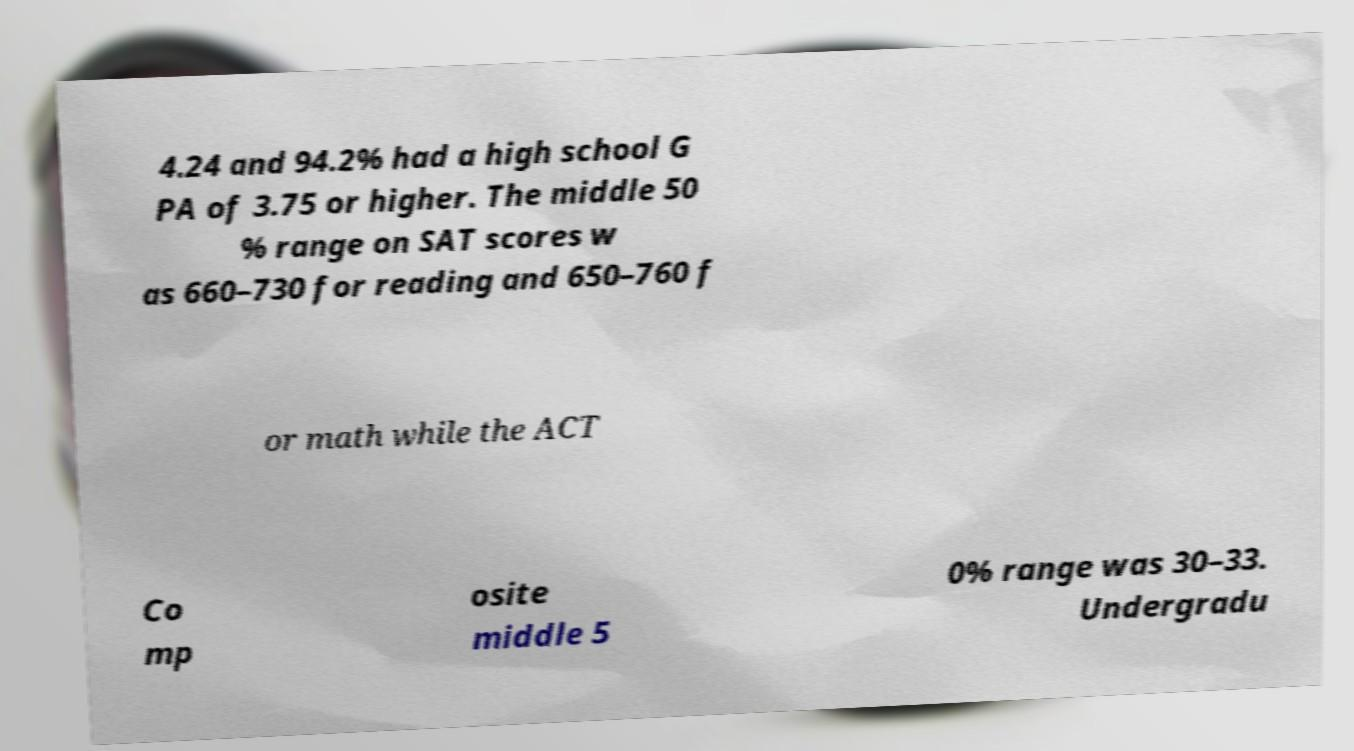Could you assist in decoding the text presented in this image and type it out clearly? 4.24 and 94.2% had a high school G PA of 3.75 or higher. The middle 50 % range on SAT scores w as 660–730 for reading and 650–760 f or math while the ACT Co mp osite middle 5 0% range was 30–33. Undergradu 